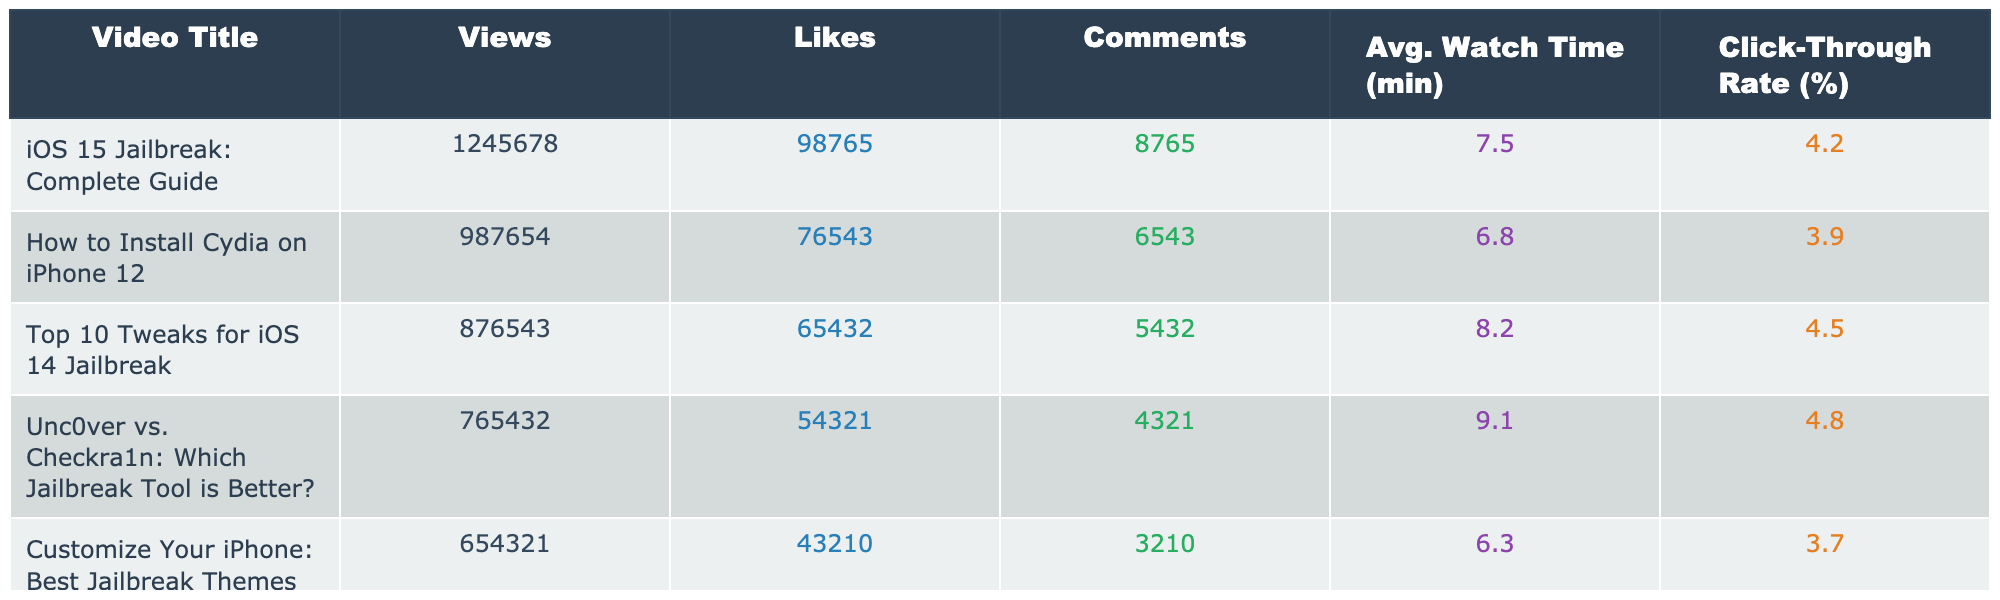What is the total number of views for the top 5 videos? To find the total views, I sum the views of all 5 videos: 1245678 + 987654 + 876543 + 765432 + 654321 = 4611628
Answer: 4611628 Which video has the highest number of likes? By examining the 'Likes' column, the video "iOS 15 Jailbreak: Complete Guide" has the most likes with 98765.
Answer: "iOS 15 Jailbreak: Complete Guide" Is the average watch time for "Customize Your iPhone: Best Jailbreak Themes 2023" greater than 6 minutes? The average watch time for this video is 6.3 minutes, which is indeed greater than 6 minutes.
Answer: Yes What is the difference in views between "Top 10 Tweaks for iOS 14 Jailbreak" and "How to Install Cydia on iPhone 12"? The difference in views is calculated by subtracting the views of "How to Install Cydia on iPhone 12" (987654) from "Top 10 Tweaks for iOS 14 Jailbreak" (876543): 987654 - 876543 = 111111.
Answer: 111111 Which video had the lowest click-through rate and what is that rate? By inspecting the 'Click-Through Rate' column, "Customize Your iPhone: Best Jailbreak Themes 2023" has the lowest rate at 3.7%.
Answer: 3.7% What is the average number of comments across all 5 videos? To compute the average, I sum the comments: 8765 + 6543 + 5432 + 4321 + 3210 = 20071, then divide by 5: 20071 / 5 = 4014.2.
Answer: 4014.2 Are there any videos with a click-through rate above 4%? By examining the Click-Through Rate column, "Unc0ver vs. Checkra1n: Which Jailbreak Tool is Better?" (4.8%), "Top 10 Tweaks for iOS 14 Jailbreak" (4.5%), and "iOS 15 Jailbreak: Complete Guide" (4.2%) all exceed 4%.
Answer: Yes Which video had the most comments overall? The video "iOS 15 Jailbreak: Complete Guide" has the most comments, with a total of 8765 comments.
Answer: 8765 